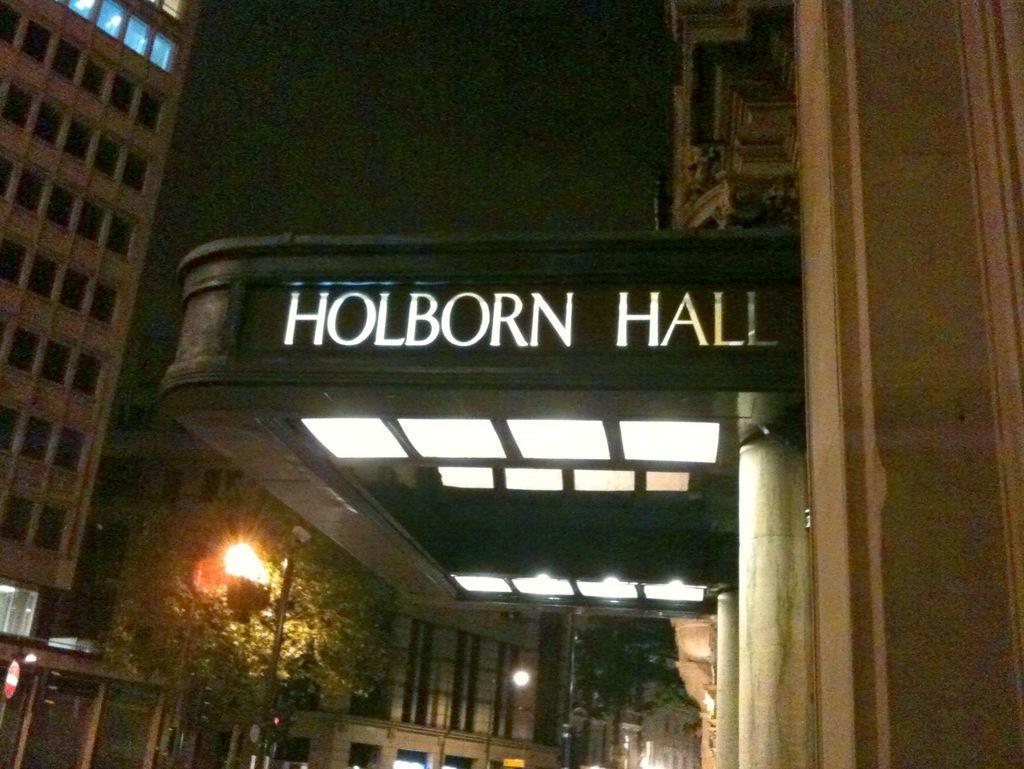Please provide a concise description of this image. This image is taken outdoors. At the top of the image there is a sky. The sky is dark. At the bottom of the image there is a street light and there is a tree. In this image there are a few buildings with walls, windows, doors and roofs. In the middle of the image there is a board with a text on it and there are a few lights. 